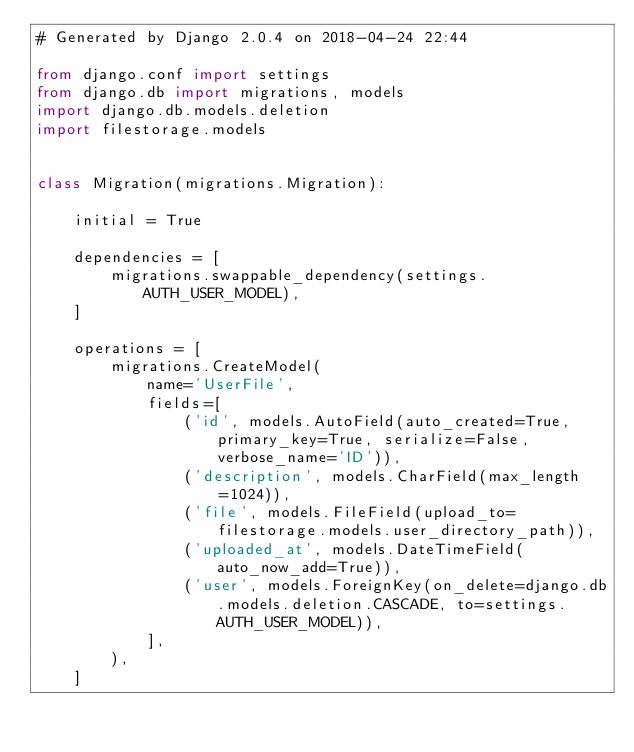Convert code to text. <code><loc_0><loc_0><loc_500><loc_500><_Python_># Generated by Django 2.0.4 on 2018-04-24 22:44

from django.conf import settings
from django.db import migrations, models
import django.db.models.deletion
import filestorage.models


class Migration(migrations.Migration):

    initial = True

    dependencies = [
        migrations.swappable_dependency(settings.AUTH_USER_MODEL),
    ]

    operations = [
        migrations.CreateModel(
            name='UserFile',
            fields=[
                ('id', models.AutoField(auto_created=True, primary_key=True, serialize=False, verbose_name='ID')),
                ('description', models.CharField(max_length=1024)),
                ('file', models.FileField(upload_to=filestorage.models.user_directory_path)),
                ('uploaded_at', models.DateTimeField(auto_now_add=True)),
                ('user', models.ForeignKey(on_delete=django.db.models.deletion.CASCADE, to=settings.AUTH_USER_MODEL)),
            ],
        ),
    ]
</code> 